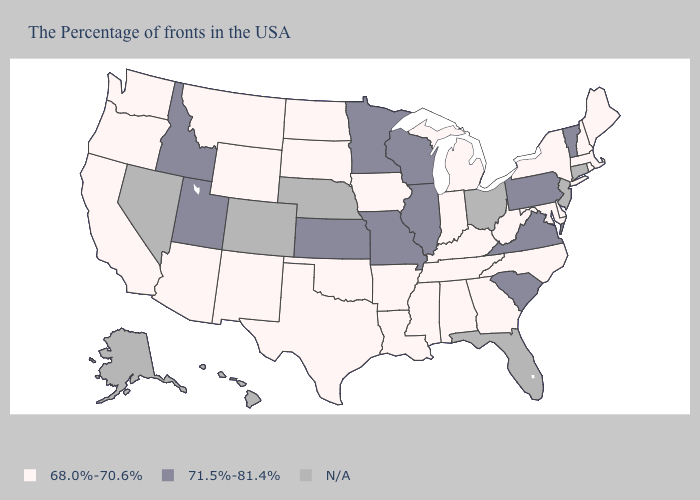What is the lowest value in the USA?
Short answer required. 68.0%-70.6%. Does Iowa have the lowest value in the MidWest?
Give a very brief answer. Yes. What is the value of Arkansas?
Write a very short answer. 68.0%-70.6%. What is the value of Idaho?
Concise answer only. 71.5%-81.4%. Name the states that have a value in the range N/A?
Answer briefly. Connecticut, New Jersey, Ohio, Florida, Nebraska, Colorado, Nevada, Alaska, Hawaii. Among the states that border Nebraska , does Wyoming have the highest value?
Quick response, please. No. Among the states that border New York , which have the lowest value?
Concise answer only. Massachusetts. Name the states that have a value in the range 68.0%-70.6%?
Quick response, please. Maine, Massachusetts, Rhode Island, New Hampshire, New York, Delaware, Maryland, North Carolina, West Virginia, Georgia, Michigan, Kentucky, Indiana, Alabama, Tennessee, Mississippi, Louisiana, Arkansas, Iowa, Oklahoma, Texas, South Dakota, North Dakota, Wyoming, New Mexico, Montana, Arizona, California, Washington, Oregon. Does Minnesota have the lowest value in the MidWest?
Short answer required. No. Name the states that have a value in the range 71.5%-81.4%?
Keep it brief. Vermont, Pennsylvania, Virginia, South Carolina, Wisconsin, Illinois, Missouri, Minnesota, Kansas, Utah, Idaho. Among the states that border Mississippi , which have the highest value?
Give a very brief answer. Alabama, Tennessee, Louisiana, Arkansas. What is the highest value in the USA?
Be succinct. 71.5%-81.4%. Which states have the highest value in the USA?
Short answer required. Vermont, Pennsylvania, Virginia, South Carolina, Wisconsin, Illinois, Missouri, Minnesota, Kansas, Utah, Idaho. What is the value of Massachusetts?
Keep it brief. 68.0%-70.6%. Which states have the highest value in the USA?
Short answer required. Vermont, Pennsylvania, Virginia, South Carolina, Wisconsin, Illinois, Missouri, Minnesota, Kansas, Utah, Idaho. 